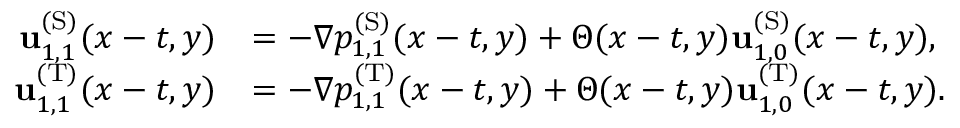Convert formula to latex. <formula><loc_0><loc_0><loc_500><loc_500>\begin{array} { r l } { u _ { 1 , 1 } ^ { ( S ) } ( x - t , y ) } & { = - \nabla p _ { 1 , 1 } ^ { ( S ) } ( x - t , y ) + \Theta ( x - t , y ) u _ { 1 , 0 } ^ { ( S ) } ( x - t , y ) , } \\ { u _ { 1 , 1 } ^ { ( T ) } ( x - t , y ) } & { = - \nabla p _ { 1 , 1 } ^ { ( T ) } ( x - t , y ) + \Theta ( x - t , y ) u _ { 1 , 0 } ^ { ( T ) } ( x - t , y ) . } \end{array}</formula> 